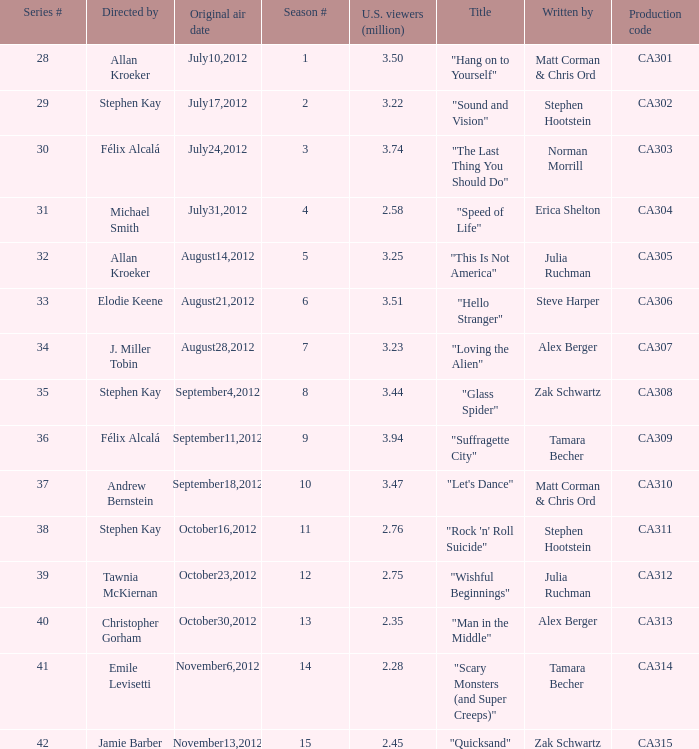Which episode had 2.75 million viewers in the U.S.? "Wishful Beginnings". 